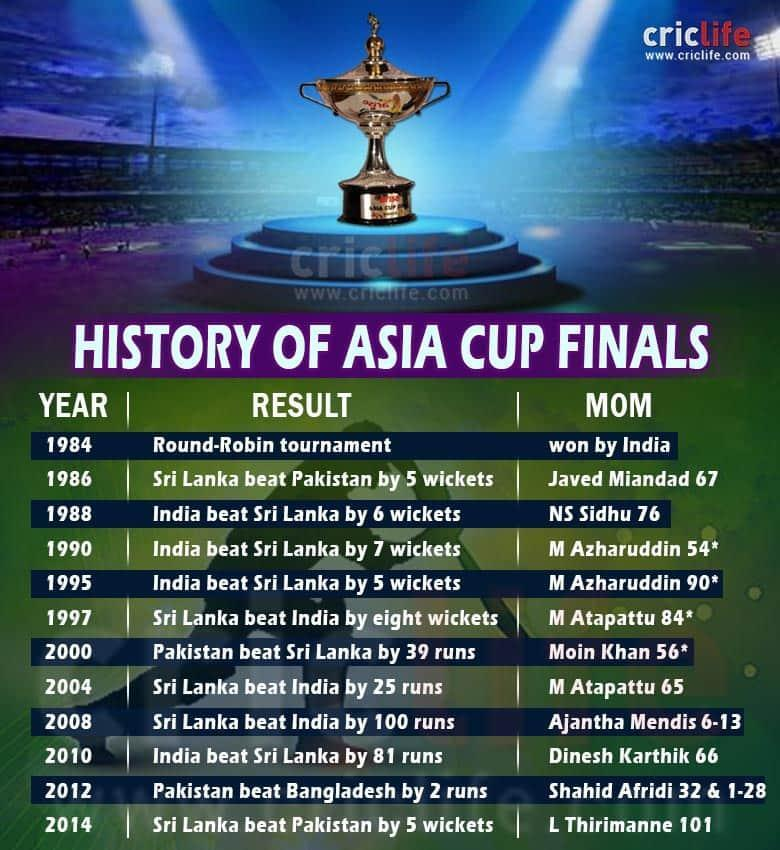Name the countries that won Asia Cup five times.
Answer the question with a short phrase. India, Sri Lanka Name the country that won Asia Cup only two times. Pakistan Who was the "MOM" in the fifth finals given in the table? M Azharuddin What is the total number of years Asia Cup was held between 1984 and 2014? 12 In which year's winning match did India beat Sri Lanka by the most number of wickets? 1990 Who was the "MOM" in the finals where Pakistan won by less than five runs? Shahid Afridi Name the country that won Asia Cup the most times after 2000. Sri Lanka Name the players who won "MOM" twice. M Azharuddin, M Atapattu 